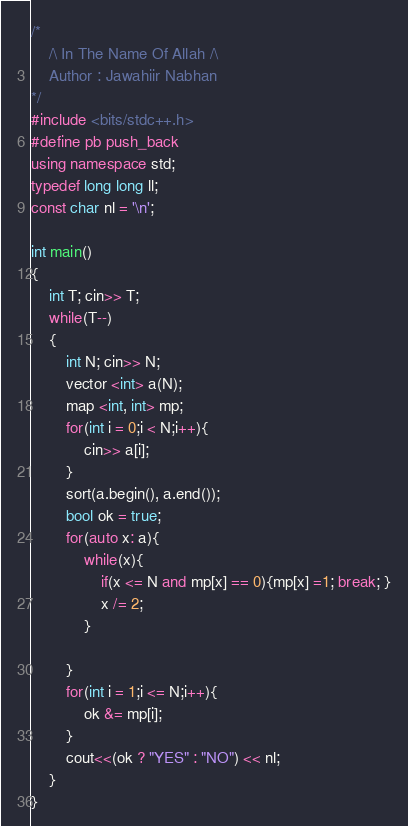Convert code to text. <code><loc_0><loc_0><loc_500><loc_500><_C++_>/*
    /\ In The Name Of Allah /\
    Author : Jawahiir Nabhan
*/
#include <bits/stdc++.h>
#define pb push_back
using namespace std;
typedef long long ll;
const char nl = '\n';

int main()
{
    int T; cin>> T;
    while(T--)
    {
        int N; cin>> N;
        vector <int> a(N);
        map <int, int> mp;
        for(int i = 0;i < N;i++){
            cin>> a[i];
        }
        sort(a.begin(), a.end());
        bool ok = true;
        for(auto x: a){
            while(x){
                if(x <= N and mp[x] == 0){mp[x] =1; break; }
                x /= 2;
            }

        }
        for(int i = 1;i <= N;i++){
            ok &= mp[i];
        }
        cout<<(ok ? "YES" : "NO") << nl;
    }
}
</code> 